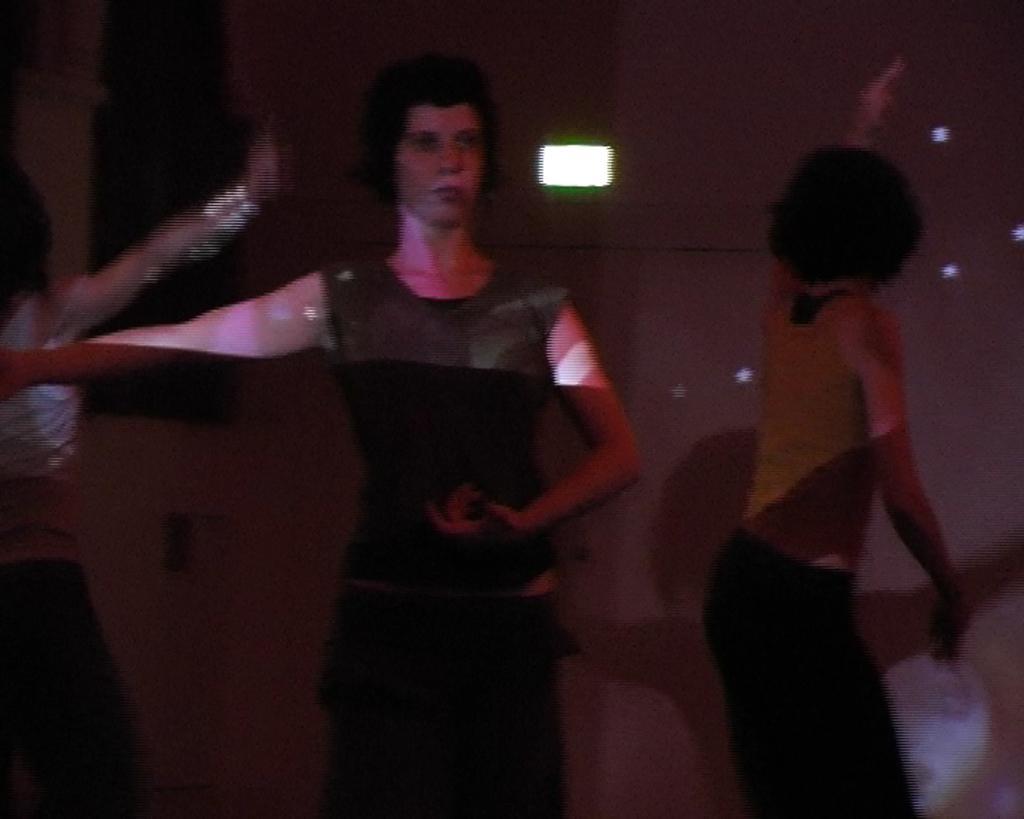Please provide a concise description of this image. In this image, there are three people dancing. In the background, I can see the lights on the wall. 